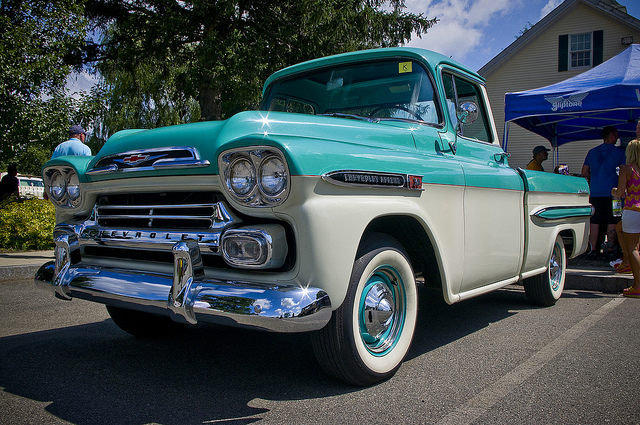What's an interesting, far-fetched story involving this truck? In an alternate universe where vehicles possess consciousness, this classic Chevrolet truck once belonged to a secret society of time-traveling vehicles. Each mission required the truck to transport its passengers not only through space but also through different eras. Its vintage appearance allowed it to blend seamlessly into the 1950s, but advanced modifications under its hood enabled it to time-hop. One day, the truck was assigned a critical mission: to recover a lost artifact from 1940s Paris. Disguised as a simple delivery vehicle, it roamed the Parisian streets, using its charm to gather intelligence. With clever maneuvers and its powerful engine, it finally located the artifact, hidden in an ancient library. As it sped back to the time portal, it dodged nearly being captured by rival vehicles from the sharegpt4v/same society. Upon returning to the present, the Chevrolet truck, humble as ever, resumed its everyday guise, parked at a local car show, its adventures unbeknownst to admirers who saw only a beautifully preserved relic from the past. 